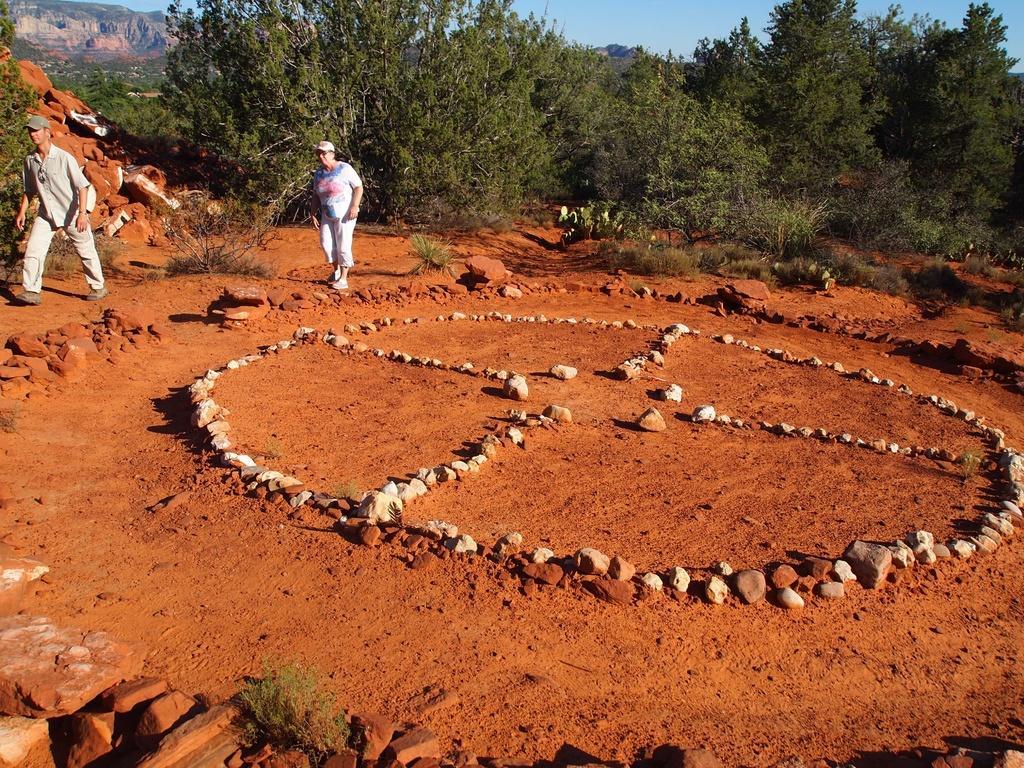Describe this image in one or two sentences. In this image I can see two people with the dresses and caps. I can see the stones, plants and many trees. In the background I can see the mountains and the sky. 